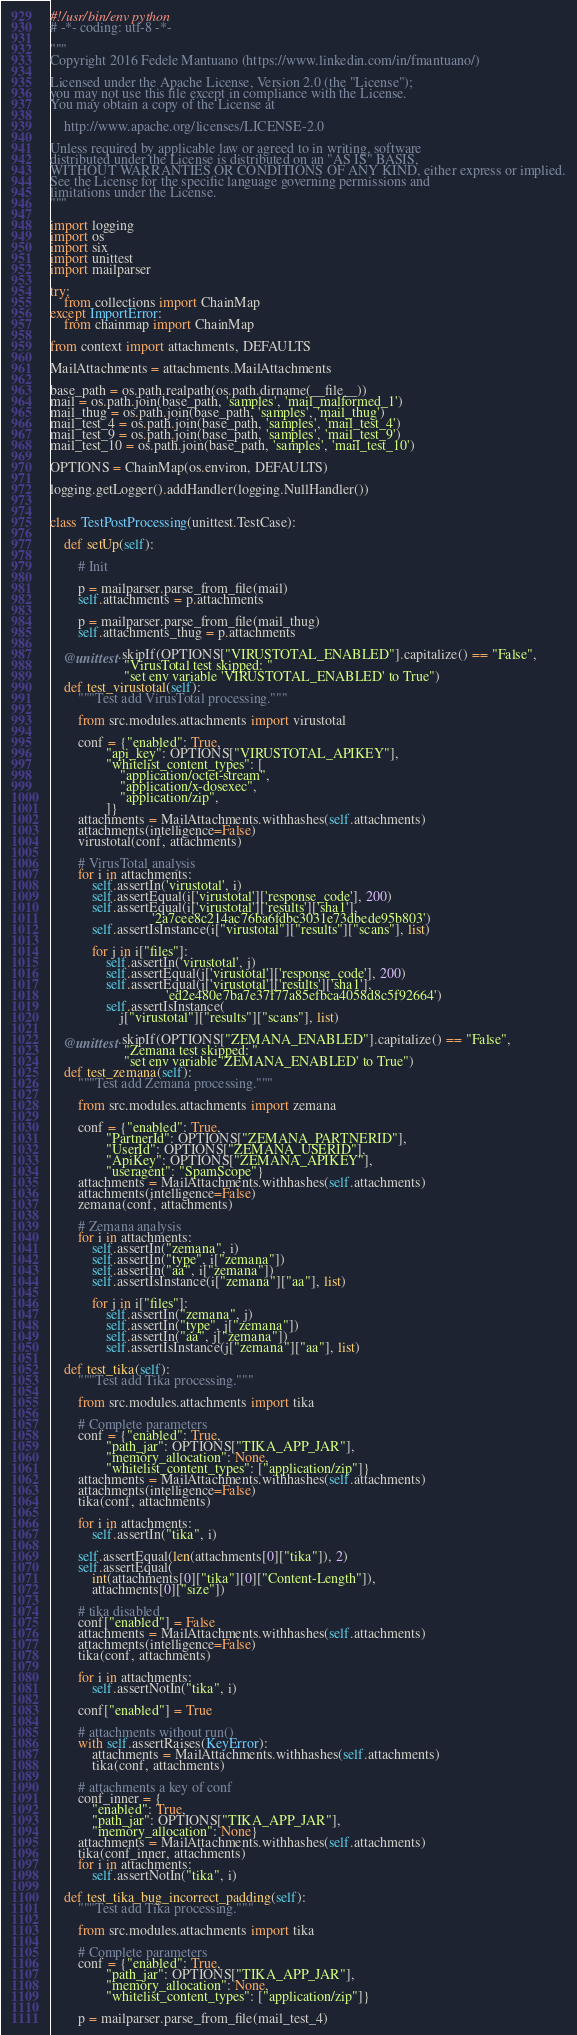<code> <loc_0><loc_0><loc_500><loc_500><_Python_>#!/usr/bin/env python
# -*- coding: utf-8 -*-

"""
Copyright 2016 Fedele Mantuano (https://www.linkedin.com/in/fmantuano/)

Licensed under the Apache License, Version 2.0 (the "License");
you may not use this file except in compliance with the License.
You may obtain a copy of the License at

    http://www.apache.org/licenses/LICENSE-2.0

Unless required by applicable law or agreed to in writing, software
distributed under the License is distributed on an "AS IS" BASIS,
WITHOUT WARRANTIES OR CONDITIONS OF ANY KIND, either express or implied.
See the License for the specific language governing permissions and
limitations under the License.
"""

import logging
import os
import six
import unittest
import mailparser

try:
    from collections import ChainMap
except ImportError:
    from chainmap import ChainMap

from context import attachments, DEFAULTS

MailAttachments = attachments.MailAttachments

base_path = os.path.realpath(os.path.dirname(__file__))
mail = os.path.join(base_path, 'samples', 'mail_malformed_1')
mail_thug = os.path.join(base_path, 'samples', 'mail_thug')
mail_test_4 = os.path.join(base_path, 'samples', 'mail_test_4')
mail_test_9 = os.path.join(base_path, 'samples', 'mail_test_9')
mail_test_10 = os.path.join(base_path, 'samples', 'mail_test_10')

OPTIONS = ChainMap(os.environ, DEFAULTS)

logging.getLogger().addHandler(logging.NullHandler())


class TestPostProcessing(unittest.TestCase):

    def setUp(self):

        # Init

        p = mailparser.parse_from_file(mail)
        self.attachments = p.attachments

        p = mailparser.parse_from_file(mail_thug)
        self.attachments_thug = p.attachments

    @unittest.skipIf(OPTIONS["VIRUSTOTAL_ENABLED"].capitalize() == "False",
                     "VirusTotal test skipped: "
                     "set env variable 'VIRUSTOTAL_ENABLED' to True")
    def test_virustotal(self):
        """Test add VirusTotal processing."""

        from src.modules.attachments import virustotal

        conf = {"enabled": True,
                "api_key": OPTIONS["VIRUSTOTAL_APIKEY"],
                "whitelist_content_types": [
                    "application/octet-stream",
                    "application/x-dosexec",
                    "application/zip",
                ]}
        attachments = MailAttachments.withhashes(self.attachments)
        attachments(intelligence=False)
        virustotal(conf, attachments)

        # VirusTotal analysis
        for i in attachments:
            self.assertIn('virustotal', i)
            self.assertEqual(i['virustotal']['response_code'], 200)
            self.assertEqual(i['virustotal']['results']['sha1'],
                             '2a7cee8c214ac76ba6fdbc3031e73dbede95b803')
            self.assertIsInstance(i["virustotal"]["results"]["scans"], list)

            for j in i["files"]:
                self.assertIn('virustotal', j)
                self.assertEqual(j['virustotal']['response_code'], 200)
                self.assertEqual(j['virustotal']['results']['sha1'],
                                 'ed2e480e7ba7e37f77a85efbca4058d8c5f92664')
                self.assertIsInstance(
                    j["virustotal"]["results"]["scans"], list)

    @unittest.skipIf(OPTIONS["ZEMANA_ENABLED"].capitalize() == "False",
                     "Zemana test skipped: "
                     "set env variable 'ZEMANA_ENABLED' to True")
    def test_zemana(self):
        """Test add Zemana processing."""

        from src.modules.attachments import zemana

        conf = {"enabled": True,
                "PartnerId": OPTIONS["ZEMANA_PARTNERID"],
                "UserId": OPTIONS["ZEMANA_USERID"],
                "ApiKey": OPTIONS["ZEMANA_APIKEY"],
                "useragent": "SpamScope"}
        attachments = MailAttachments.withhashes(self.attachments)
        attachments(intelligence=False)
        zemana(conf, attachments)

        # Zemana analysis
        for i in attachments:
            self.assertIn("zemana", i)
            self.assertIn("type", i["zemana"])
            self.assertIn("aa", i["zemana"])
            self.assertIsInstance(i["zemana"]["aa"], list)

            for j in i["files"]:
                self.assertIn("zemana", j)
                self.assertIn("type", j["zemana"])
                self.assertIn("aa", j["zemana"])
                self.assertIsInstance(j["zemana"]["aa"], list)

    def test_tika(self):
        """Test add Tika processing."""

        from src.modules.attachments import tika

        # Complete parameters
        conf = {"enabled": True,
                "path_jar": OPTIONS["TIKA_APP_JAR"],
                "memory_allocation": None,
                "whitelist_content_types": ["application/zip"]}
        attachments = MailAttachments.withhashes(self.attachments)
        attachments(intelligence=False)
        tika(conf, attachments)

        for i in attachments:
            self.assertIn("tika", i)

        self.assertEqual(len(attachments[0]["tika"]), 2)
        self.assertEqual(
            int(attachments[0]["tika"][0]["Content-Length"]),
            attachments[0]["size"])

        # tika disabled
        conf["enabled"] = False
        attachments = MailAttachments.withhashes(self.attachments)
        attachments(intelligence=False)
        tika(conf, attachments)

        for i in attachments:
            self.assertNotIn("tika", i)

        conf["enabled"] = True

        # attachments without run()
        with self.assertRaises(KeyError):
            attachments = MailAttachments.withhashes(self.attachments)
            tika(conf, attachments)

        # attachments a key of conf
        conf_inner = {
            "enabled": True,
            "path_jar": OPTIONS["TIKA_APP_JAR"],
            "memory_allocation": None}
        attachments = MailAttachments.withhashes(self.attachments)
        tika(conf_inner, attachments)
        for i in attachments:
            self.assertNotIn("tika", i)

    def test_tika_bug_incorrect_padding(self):
        """Test add Tika processing."""

        from src.modules.attachments import tika

        # Complete parameters
        conf = {"enabled": True,
                "path_jar": OPTIONS["TIKA_APP_JAR"],
                "memory_allocation": None,
                "whitelist_content_types": ["application/zip"]}

        p = mailparser.parse_from_file(mail_test_4)</code> 